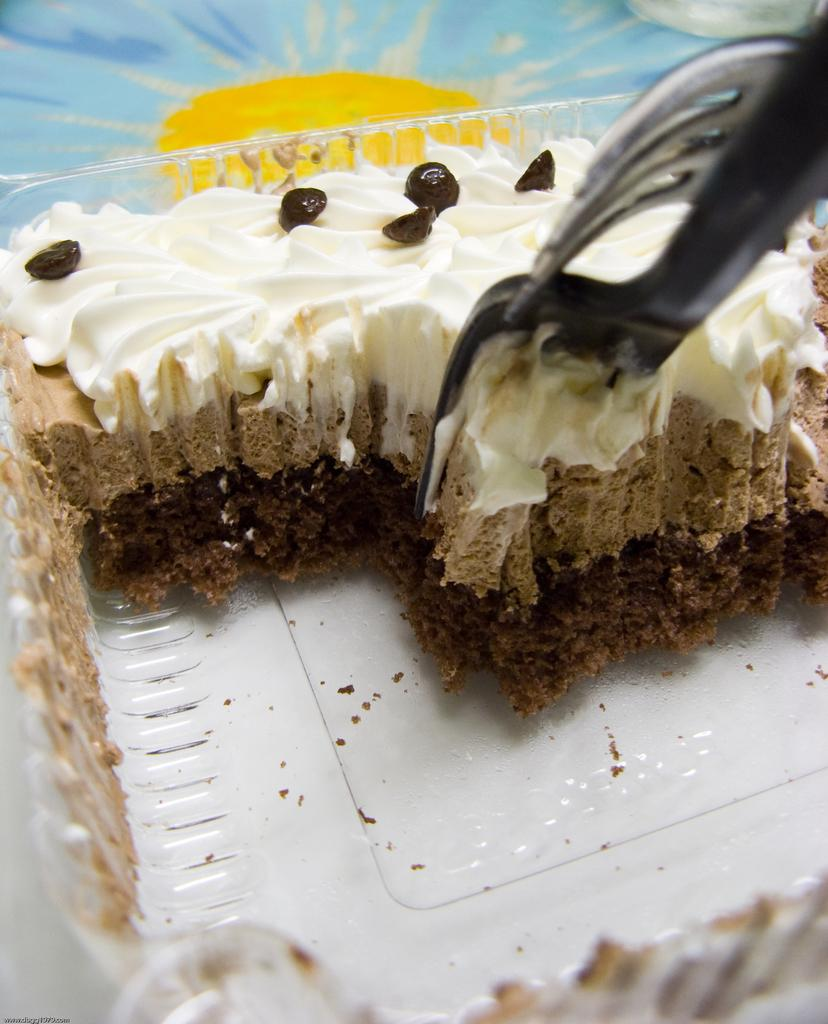What color is the bowl in the image? The bowl in the image is white. What is inside the bowl? The bowl contains cake. What utensils are in the bowl? There are forks in the bowl. What colors are visible at the top of the image? The top of the image has yellow and blue colors. Where is the leather throne located in the image? There is no leather throne present in the image. 